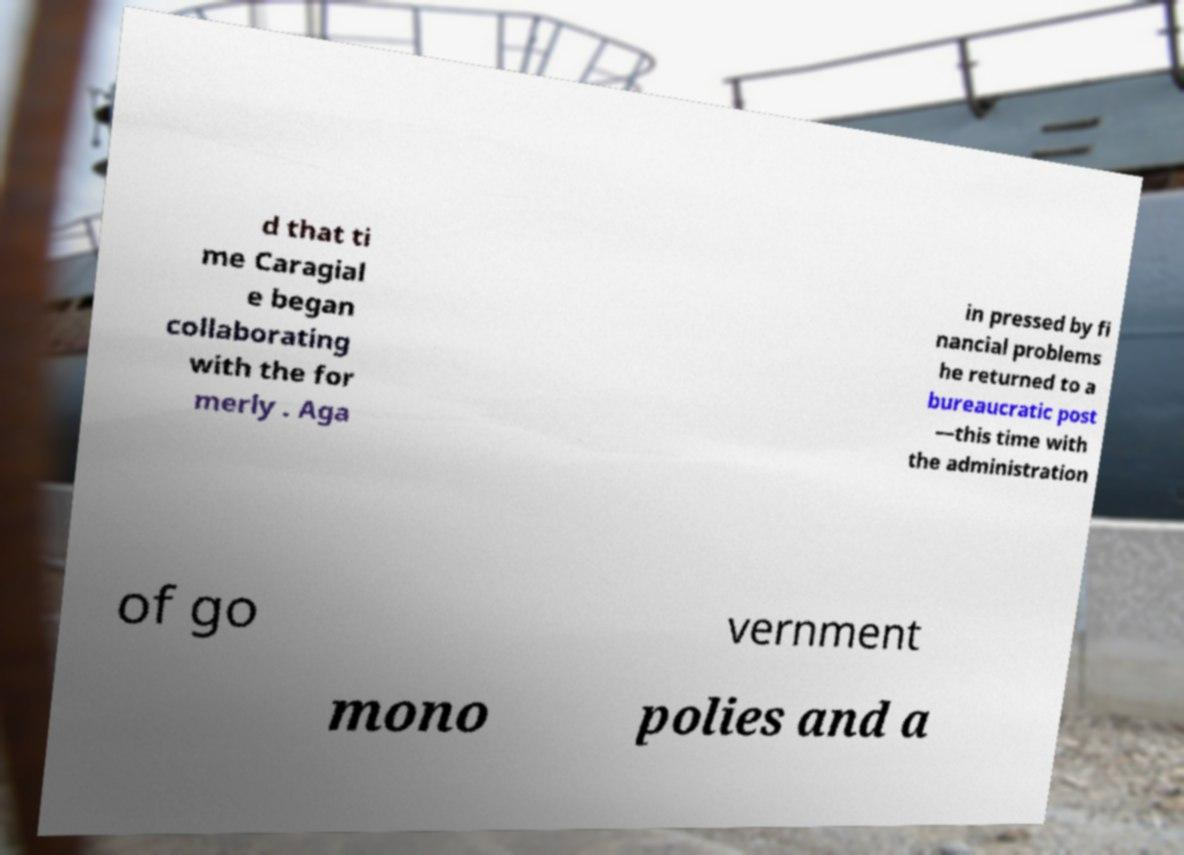I need the written content from this picture converted into text. Can you do that? d that ti me Caragial e began collaborating with the for merly . Aga in pressed by fi nancial problems he returned to a bureaucratic post —this time with the administration of go vernment mono polies and a 